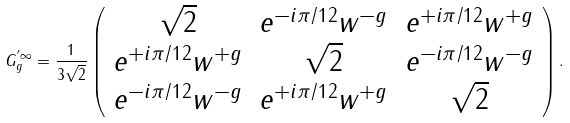Convert formula to latex. <formula><loc_0><loc_0><loc_500><loc_500>G _ { g } ^ { ^ { \prime } \infty } = \frac { 1 } { 3 \sqrt { 2 } } \left ( \begin{array} { c c c } \sqrt { 2 } & e ^ { - i \pi / 1 2 } w ^ { - g } & e ^ { + i \pi / 1 2 } w ^ { + g } \\ e ^ { + i \pi / 1 2 } w ^ { + g } & \sqrt { 2 } & e ^ { - i \pi / 1 2 } w ^ { - g } \\ e ^ { - i \pi / 1 2 } w ^ { - g } & e ^ { + i \pi / 1 2 } w ^ { + g } & \sqrt { 2 } \end{array} \right ) .</formula> 